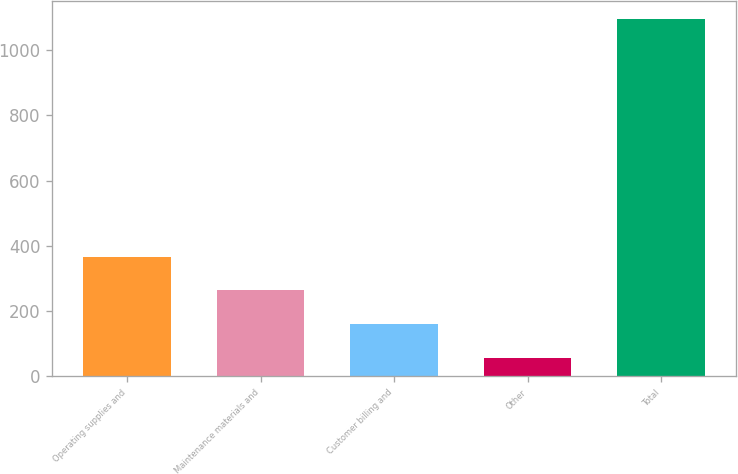Convert chart to OTSL. <chart><loc_0><loc_0><loc_500><loc_500><bar_chart><fcel>Operating supplies and<fcel>Maintenance materials and<fcel>Customer billing and<fcel>Other<fcel>Total<nl><fcel>367.7<fcel>263.8<fcel>159.9<fcel>56<fcel>1095<nl></chart> 